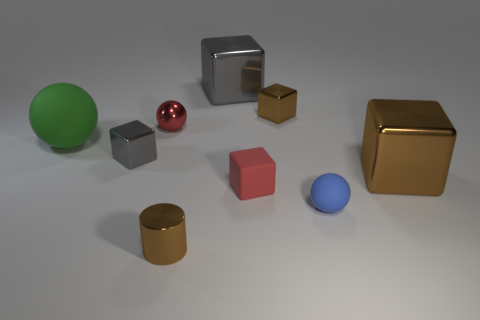There is a blue object to the left of the large cube in front of the large green rubber sphere; what size is it?
Offer a terse response. Small. What is the size of the metallic object that is the same color as the small matte block?
Provide a short and direct response. Small. What number of other objects are the same size as the metallic ball?
Give a very brief answer. 5. What number of tiny red shiny spheres are there?
Offer a terse response. 1. Do the red rubber block and the brown shiny cylinder have the same size?
Provide a short and direct response. Yes. How many other objects are the same shape as the green matte thing?
Your answer should be very brief. 2. The red object to the right of the brown metallic thing that is on the left side of the red matte cube is made of what material?
Ensure brevity in your answer.  Rubber. There is a tiny gray metallic block; are there any gray shiny blocks on the right side of it?
Provide a succinct answer. Yes. There is a blue rubber object; is its size the same as the sphere behind the large green ball?
Give a very brief answer. Yes. There is a red thing that is the same shape as the green thing; what is its size?
Give a very brief answer. Small. 